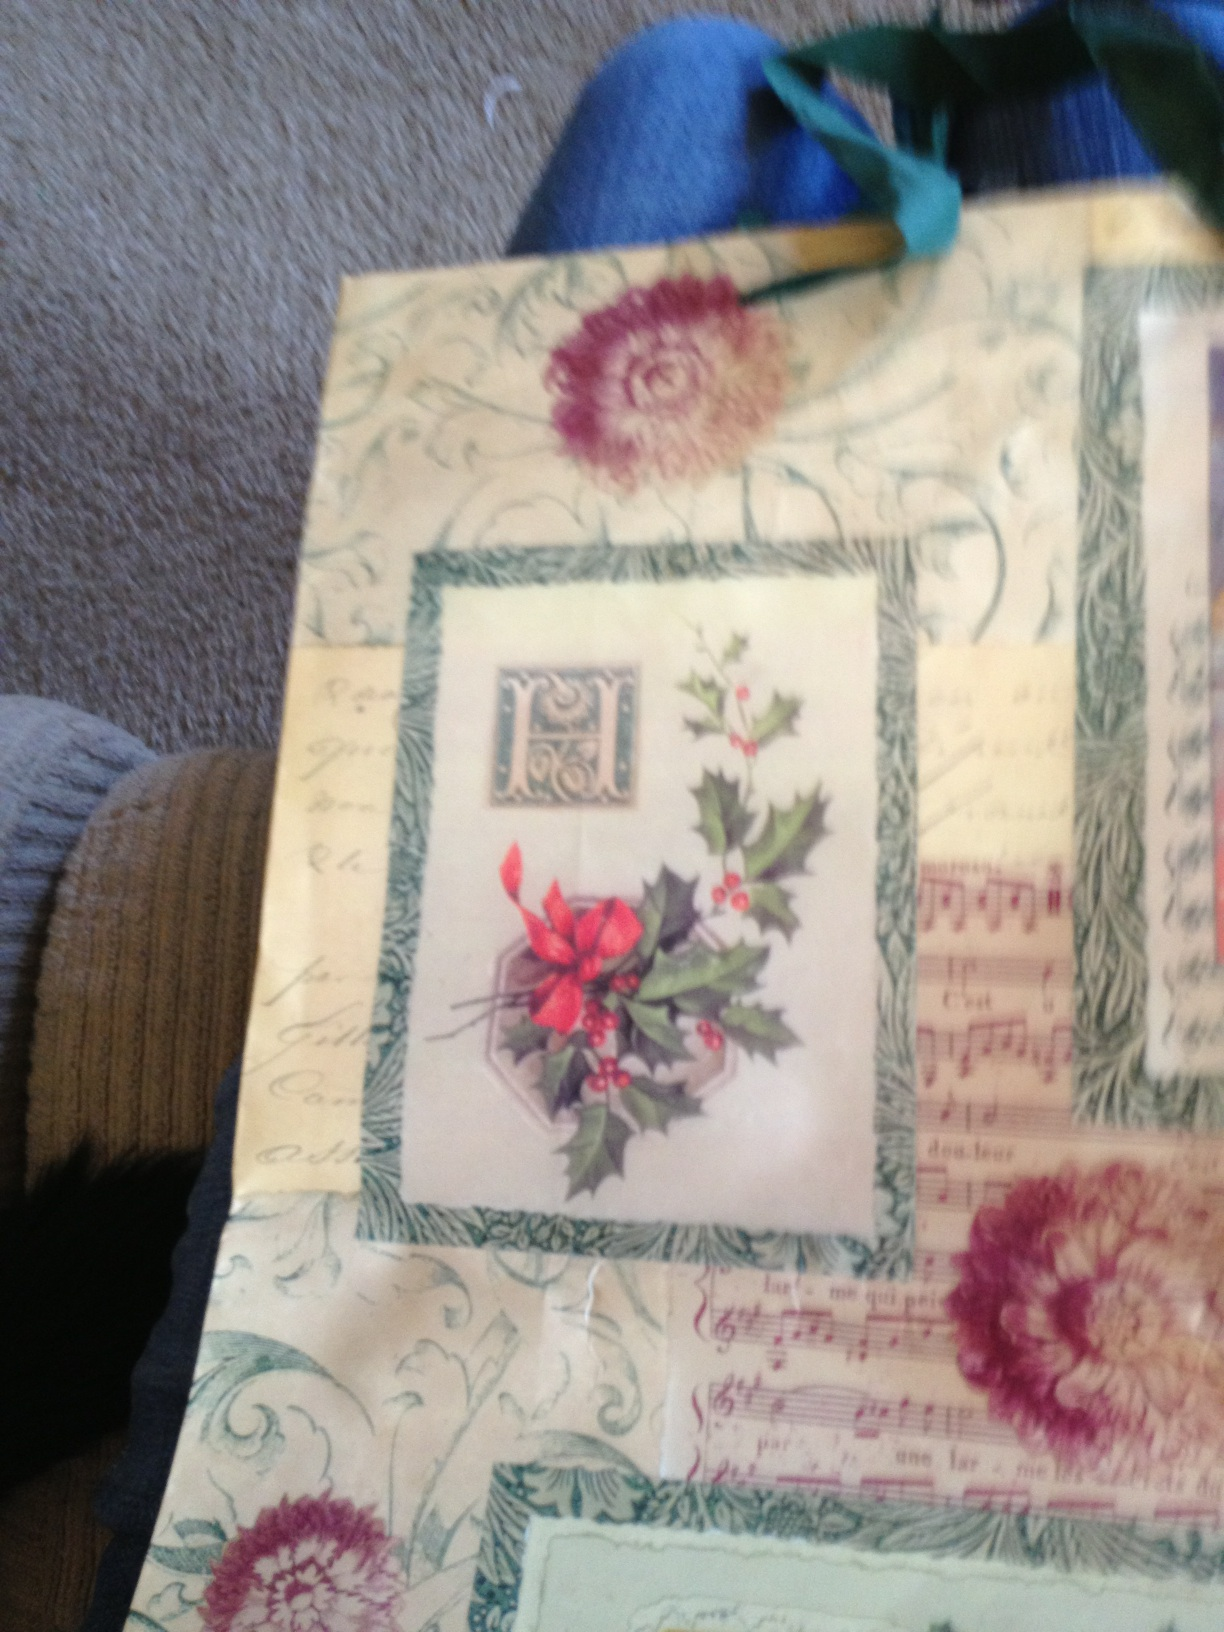Can you describe the overall theme of this gift bag? The gift bag has a vintage Christmas theme, showcasing festive elements such as holly with red berries, classic sheet music, and intricate, old-fashioned patterns. It embodies a warm, nostalgic holiday spirit. What kind of occasion would this gift bag be most appropriate for? This gift bag would be most appropriate for Christmas or any winter holiday celebration, given its festive design and nostalgic charm. Do you think the design has any historical significance? The presence of sheet music and vintage motifs suggests a tribute to classic holiday traditions, evoking the nostalgic, heartwarming spirit of Christmases past. The holly and ornamental designs further reinforce this traditional holiday aesthetic. 